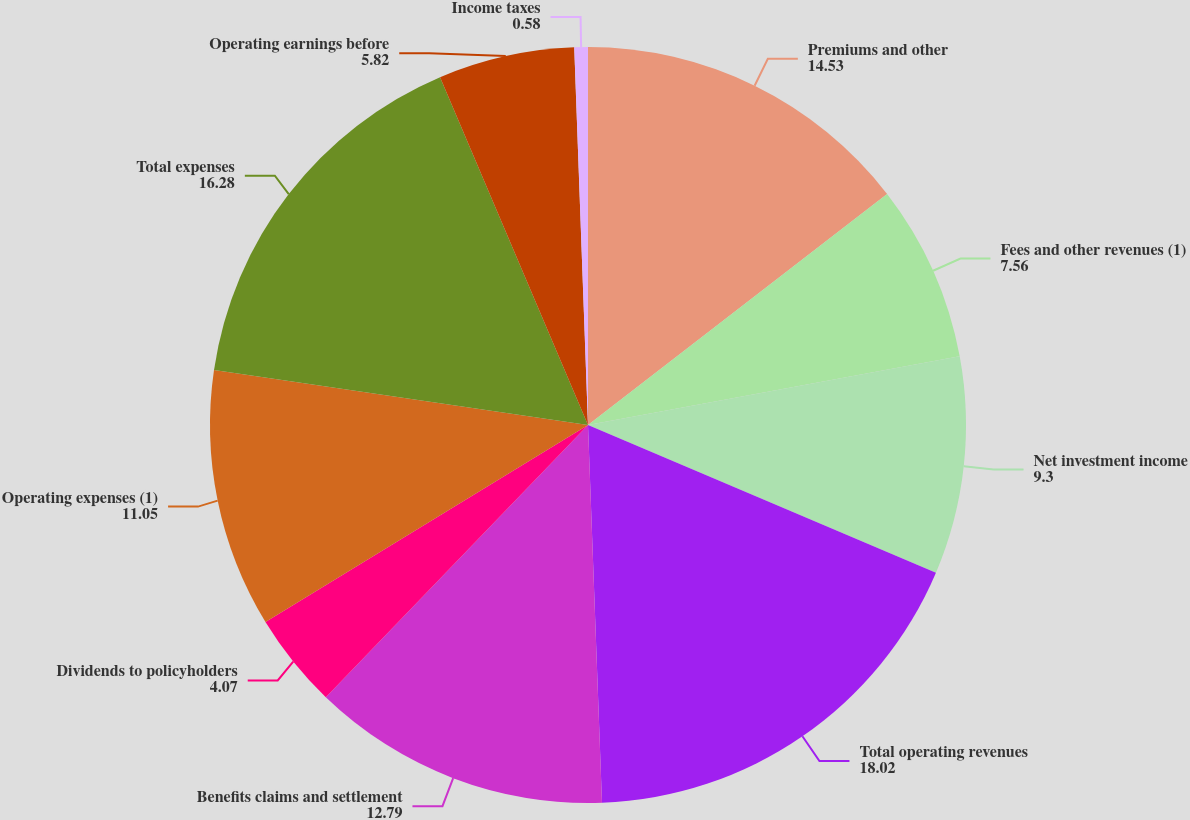Convert chart to OTSL. <chart><loc_0><loc_0><loc_500><loc_500><pie_chart><fcel>Premiums and other<fcel>Fees and other revenues (1)<fcel>Net investment income<fcel>Total operating revenues<fcel>Benefits claims and settlement<fcel>Dividends to policyholders<fcel>Operating expenses (1)<fcel>Total expenses<fcel>Operating earnings before<fcel>Income taxes<nl><fcel>14.53%<fcel>7.56%<fcel>9.3%<fcel>18.02%<fcel>12.79%<fcel>4.07%<fcel>11.05%<fcel>16.28%<fcel>5.82%<fcel>0.58%<nl></chart> 